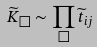<formula> <loc_0><loc_0><loc_500><loc_500>\widetilde { K } _ { \Box } \sim \prod _ { \Box } \widetilde { t } _ { i j }</formula> 